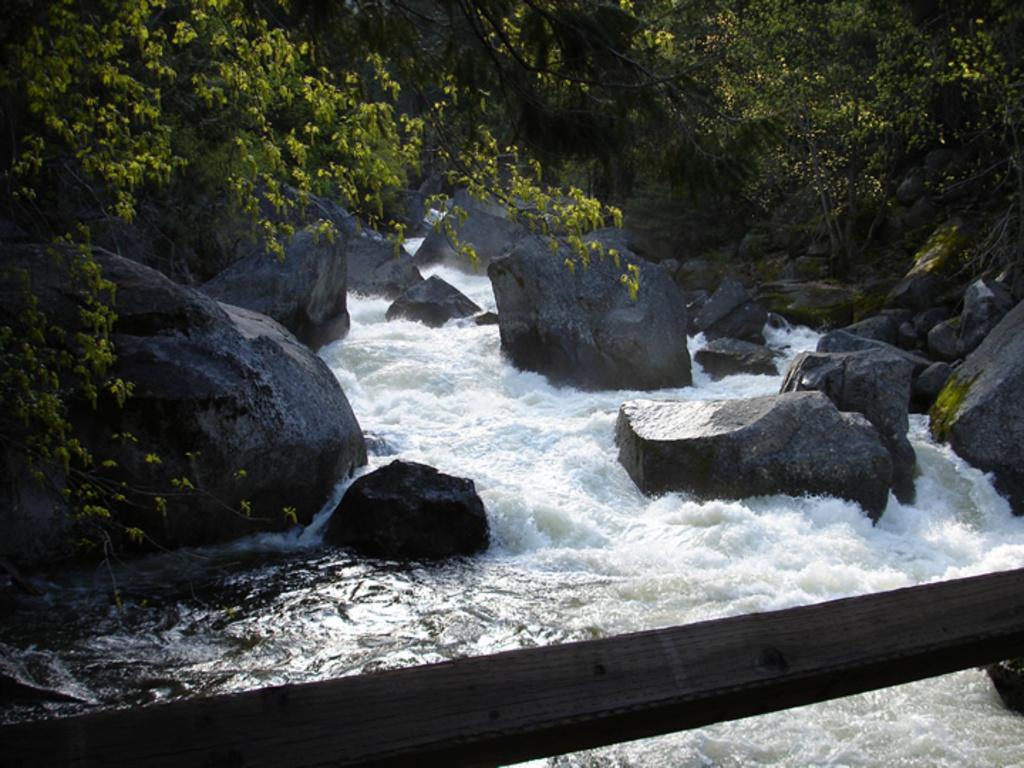Can you describe this image briefly? At the bottom we can see a wooden pole. In the background we can see water is flowing and there are rocks and stones in the water and we can see trees. 